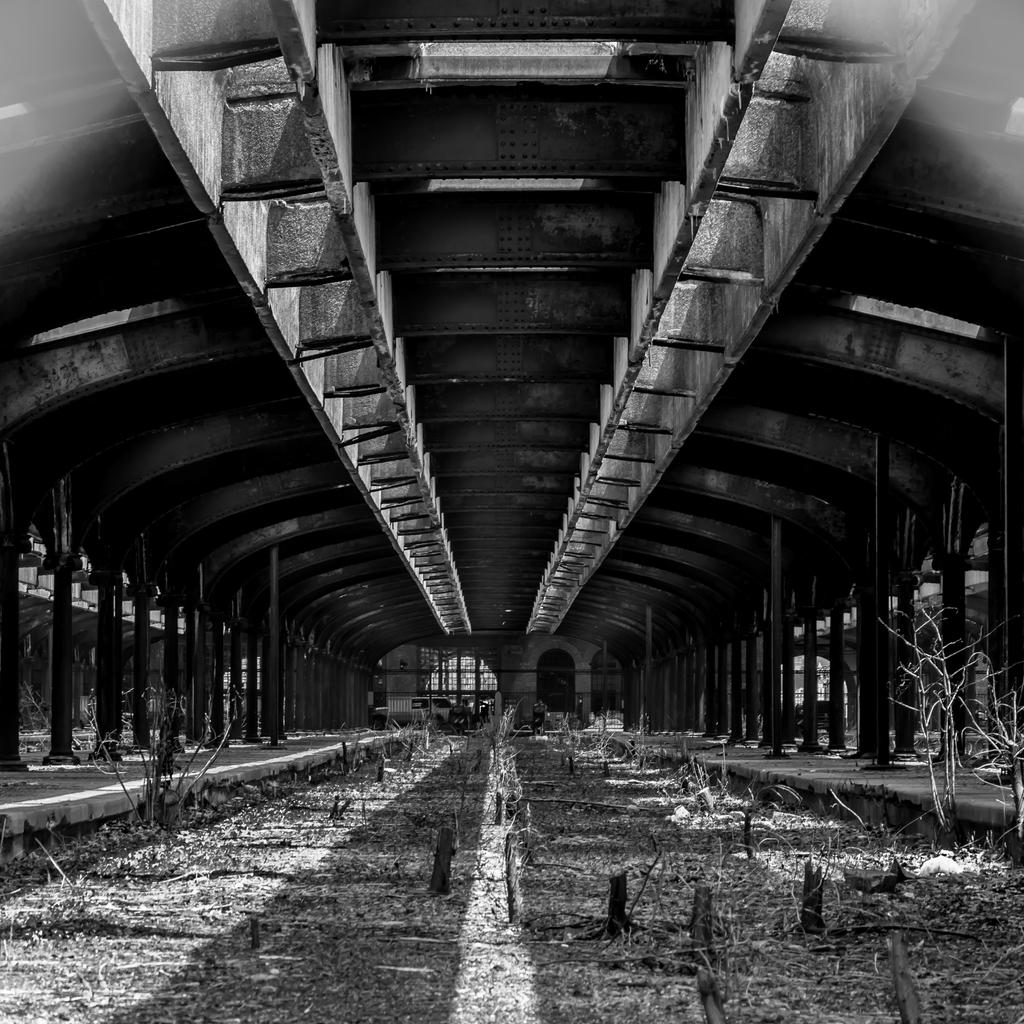What objects can be seen in the image? There are rods in the image. What type of natural elements are visible in the image? There are trees visible in the image. What structure can be seen at the top of the image? There is a roof at the top of the image. What is the price of the doll in the image? There is no doll present in the image, so it is not possible to determine its price. 